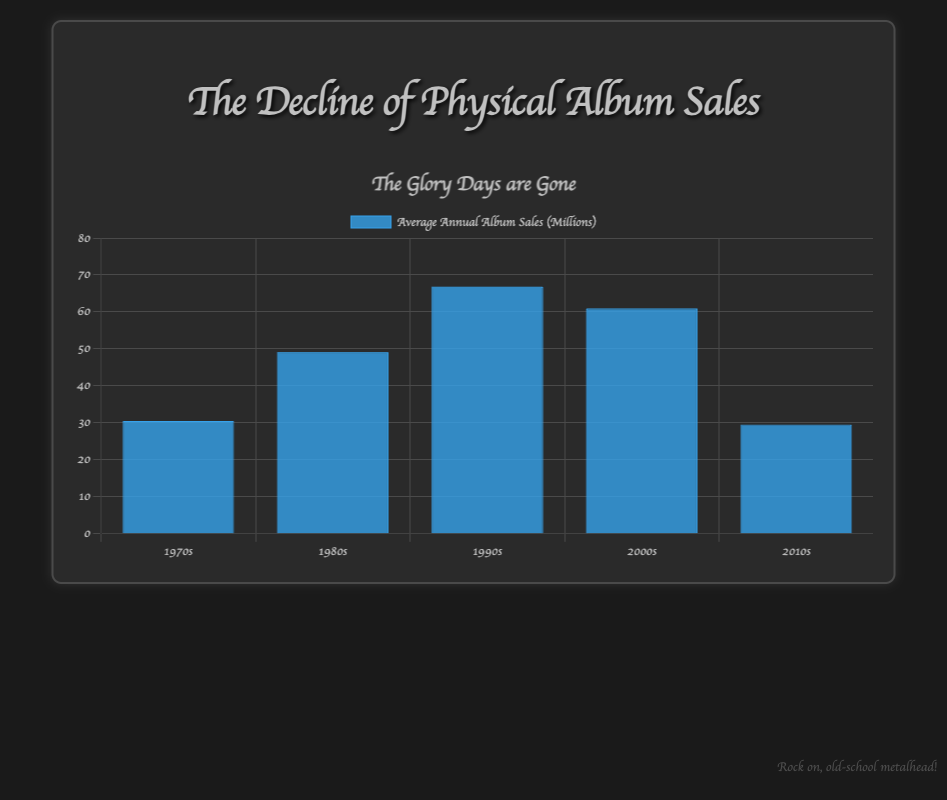What's the average annual album sales in the 1980s? Summing the sales from 1980 to 1989: 42, 43, 45, 46, 48, 50, 52, 53, 55, 57 gives 491. There are 10 values. Therefore, the average is 491/10 = 49.1.
Answer: 49.1 Which decade had the highest annual sales on average? By inspecting the height of the bars, the bar representing the average sales for the 2000s peaks the highest.
Answer: 2000s How do the average annual sales in the 2010s compare to the 1970s? The 2010s bar is slightly shorter than the 1970s bar, indicating lower average sales.
Answer: Lower What is the trend in album sales from the 1990s to the 2010s? The blue bars progressively decrease in height from the 1990s to the 2010s, indicating a decline in average annual album sales.
Answer: Declining Which decade saw the largest decline in average annual album sales? Observing the bars, the greatest drop seems to be from the 2000s to the 2010s, as the bar height significantly decreases here.
Answer: 2010s What is the average annual album sales in the 1990s? Summing the sales from 1990 to 1999: 58, 60, 62, 64, 66, 68, 70, 72, 73, 75 gives 668. There are 10 values. Therefore, the average is 668/10 = 66.8.
Answer: 66.8 By how much did the average annual sales increase from the 1970s to the 1980s? Average for 1970s is 30.5 and for 1980s is 49.1; hence, 49.1 - 30.5 = 18.6 million albums.
Answer: 18.6 Which decade showed a decline compared to the previous one? The 2000s have a lower average than the 1990s, and the 2010s have an even lower average than both the 2000s and the 1990s.
Answer: 2000s, 2010s What was the trend in album sales during the 2000s? First half (2000-2001): increasing trend. Second half (2002-2009): straight decline.
Answer: Increasing, then declining 